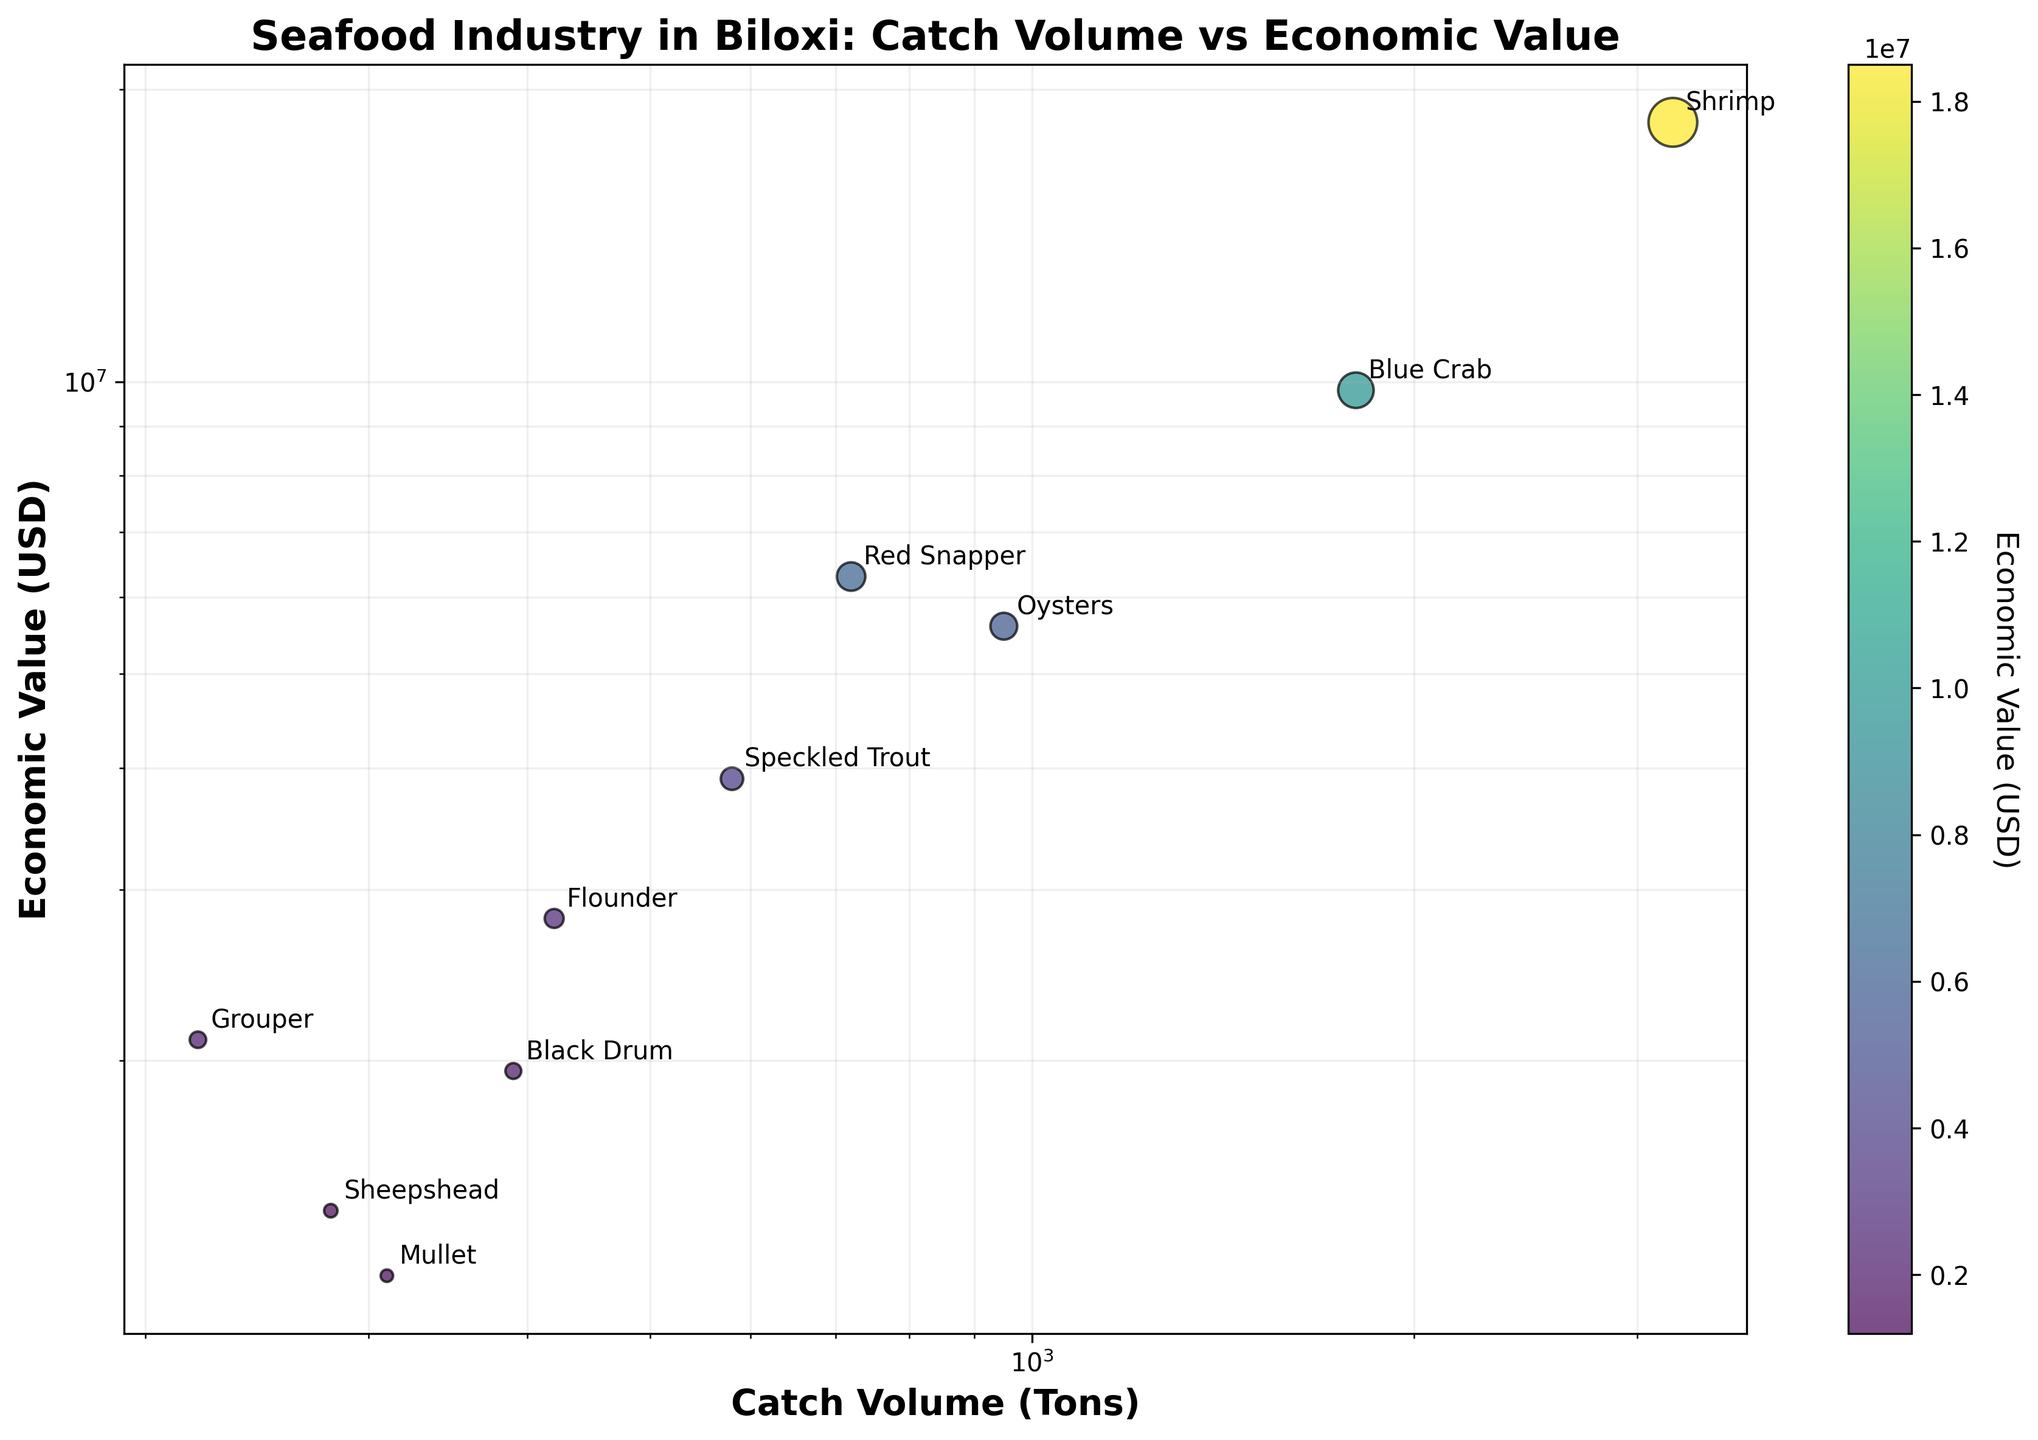What's the title of the figure? The title is located at the top of the figure and summarizes the content of the plot. It reads "Seafood Industry in Biloxi: Catch Volume vs Economic Value".
Answer: Seafood Industry in Biloxi: Catch Volume vs Economic Value Which species has the highest economic value? By looking at the y-axis (Economic Value USD) and the associated bubble size, the species with the highest economic value is "Shrimp".
Answer: Shrimp What's the economic value of Speckled Trout? Find the bubble annotated with "Speckled Trout" and refer to its position on the y-axis. The economic value is approximately 3,900,000 USD.
Answer: 3,900,000 USD Which species has the smallest catch volume? Based on the x-axis (Catch Volume Tons), the species with the smallest catch volume is "Grouper".
Answer: Grouper How many species are depicted in the figure? Count the individual bubbles, which represent different species; there are 10 species in total.
Answer: 10 Which species has a higher economic value: Flounder or Mullet? Compare the y-axis positions of the bubbles labeled "Flounder" and "Mullet". Flounder has an economic value of approximately 2,800,000 USD, while Mullet has 1,200,000 USD, so Flounder has a higher economic value.
Answer: Flounder What is the average economic value of Blue Crab and Red Snapper? Blue Crab has an economic value of 9,800,000 USD and Red Snapper has 6,300,000 USD. To find the average: (9,800,000 + 6,300,000) / 2 = 8,050,000 USD.
Answer: 8,050,000 USD Which species' bubble is the largest, and why? The size of the bubble is proportional to the economic value; therefore, the largest bubble represents "Shrimp", which has the highest economic value.
Answer: Shrimp Is the relationship between Catch Volume and Economic Value linear or non-linear? Given the log-log scale of both axes and the non-linear spread of the bubbles, the relationship appears to be non-linear.
Answer: Non-linear Identify a species that balances both high catch volume and economic value. Look for a species with a relatively high position on both axes; "Blue Crab" stands out with a catch volume of 1,800 tons and an economic value of 9,800,000 USD.
Answer: Blue Crab 